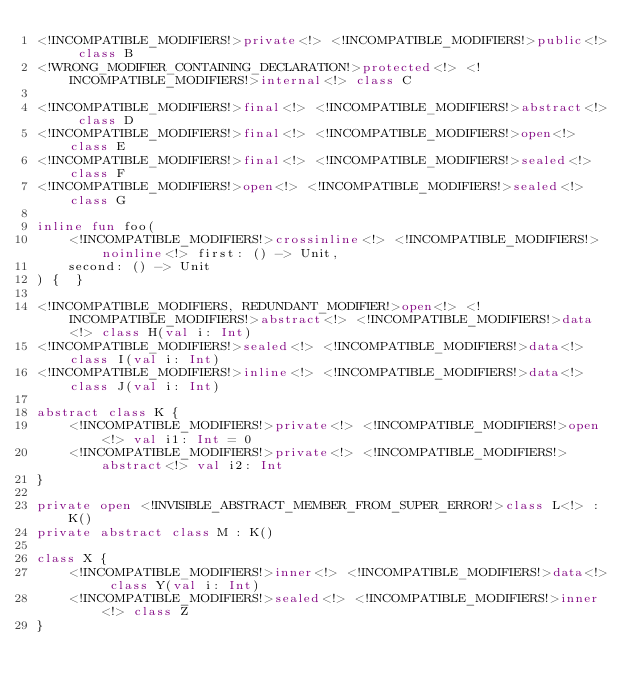Convert code to text. <code><loc_0><loc_0><loc_500><loc_500><_Kotlin_><!INCOMPATIBLE_MODIFIERS!>private<!> <!INCOMPATIBLE_MODIFIERS!>public<!> class B
<!WRONG_MODIFIER_CONTAINING_DECLARATION!>protected<!> <!INCOMPATIBLE_MODIFIERS!>internal<!> class C

<!INCOMPATIBLE_MODIFIERS!>final<!> <!INCOMPATIBLE_MODIFIERS!>abstract<!> class D
<!INCOMPATIBLE_MODIFIERS!>final<!> <!INCOMPATIBLE_MODIFIERS!>open<!> class E
<!INCOMPATIBLE_MODIFIERS!>final<!> <!INCOMPATIBLE_MODIFIERS!>sealed<!> class F
<!INCOMPATIBLE_MODIFIERS!>open<!> <!INCOMPATIBLE_MODIFIERS!>sealed<!> class G

inline fun foo(
    <!INCOMPATIBLE_MODIFIERS!>crossinline<!> <!INCOMPATIBLE_MODIFIERS!>noinline<!> first: () -> Unit,
    second: () -> Unit
) {  }

<!INCOMPATIBLE_MODIFIERS, REDUNDANT_MODIFIER!>open<!> <!INCOMPATIBLE_MODIFIERS!>abstract<!> <!INCOMPATIBLE_MODIFIERS!>data<!> class H(val i: Int)
<!INCOMPATIBLE_MODIFIERS!>sealed<!> <!INCOMPATIBLE_MODIFIERS!>data<!> class I(val i: Int)
<!INCOMPATIBLE_MODIFIERS!>inline<!> <!INCOMPATIBLE_MODIFIERS!>data<!> class J(val i: Int)

abstract class K {
    <!INCOMPATIBLE_MODIFIERS!>private<!> <!INCOMPATIBLE_MODIFIERS!>open<!> val i1: Int = 0
    <!INCOMPATIBLE_MODIFIERS!>private<!> <!INCOMPATIBLE_MODIFIERS!>abstract<!> val i2: Int
}

private open <!INVISIBLE_ABSTRACT_MEMBER_FROM_SUPER_ERROR!>class L<!> : K()
private abstract class M : K()

class X {
    <!INCOMPATIBLE_MODIFIERS!>inner<!> <!INCOMPATIBLE_MODIFIERS!>data<!> class Y(val i: Int)
    <!INCOMPATIBLE_MODIFIERS!>sealed<!> <!INCOMPATIBLE_MODIFIERS!>inner<!> class Z
}
</code> 